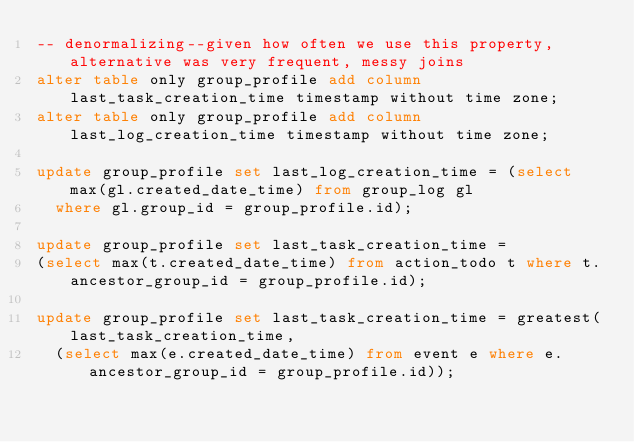<code> <loc_0><loc_0><loc_500><loc_500><_SQL_>-- denormalizing--given how often we use this property, alternative was very frequent, messy joins
alter table only group_profile add column last_task_creation_time timestamp without time zone;
alter table only group_profile add column last_log_creation_time timestamp without time zone;

update group_profile set last_log_creation_time = (select max(gl.created_date_time) from group_log gl
  where gl.group_id = group_profile.id);

update group_profile set last_task_creation_time =
(select max(t.created_date_time) from action_todo t where t.ancestor_group_id = group_profile.id);

update group_profile set last_task_creation_time = greatest(last_task_creation_time,
  (select max(e.created_date_time) from event e where e.ancestor_group_id = group_profile.id));</code> 